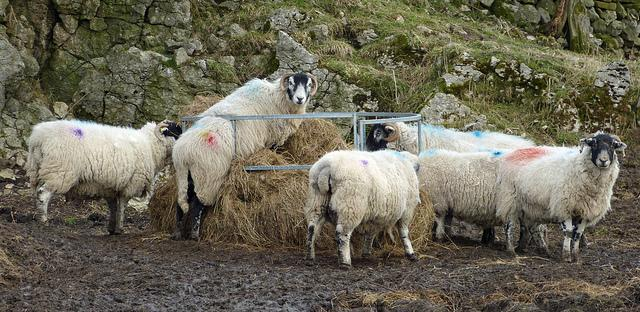What word is related to these animals? sheep 